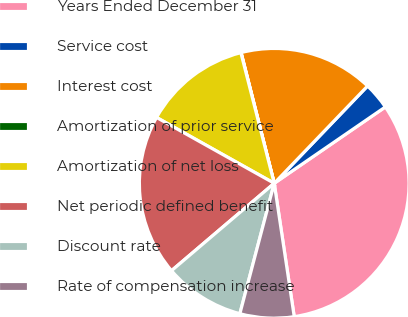<chart> <loc_0><loc_0><loc_500><loc_500><pie_chart><fcel>Years Ended December 31<fcel>Service cost<fcel>Interest cost<fcel>Amortization of prior service<fcel>Amortization of net loss<fcel>Net periodic defined benefit<fcel>Discount rate<fcel>Rate of compensation increase<nl><fcel>32.21%<fcel>3.25%<fcel>16.12%<fcel>0.03%<fcel>12.9%<fcel>19.34%<fcel>9.68%<fcel>6.47%<nl></chart> 